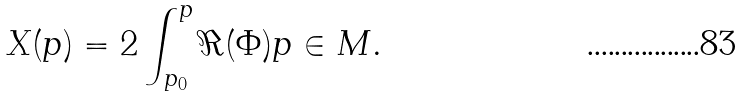Convert formula to latex. <formula><loc_0><loc_0><loc_500><loc_500>X ( p ) = 2 \int _ { p _ { 0 } } ^ { p } \Re ( \Phi ) p \in M .</formula> 